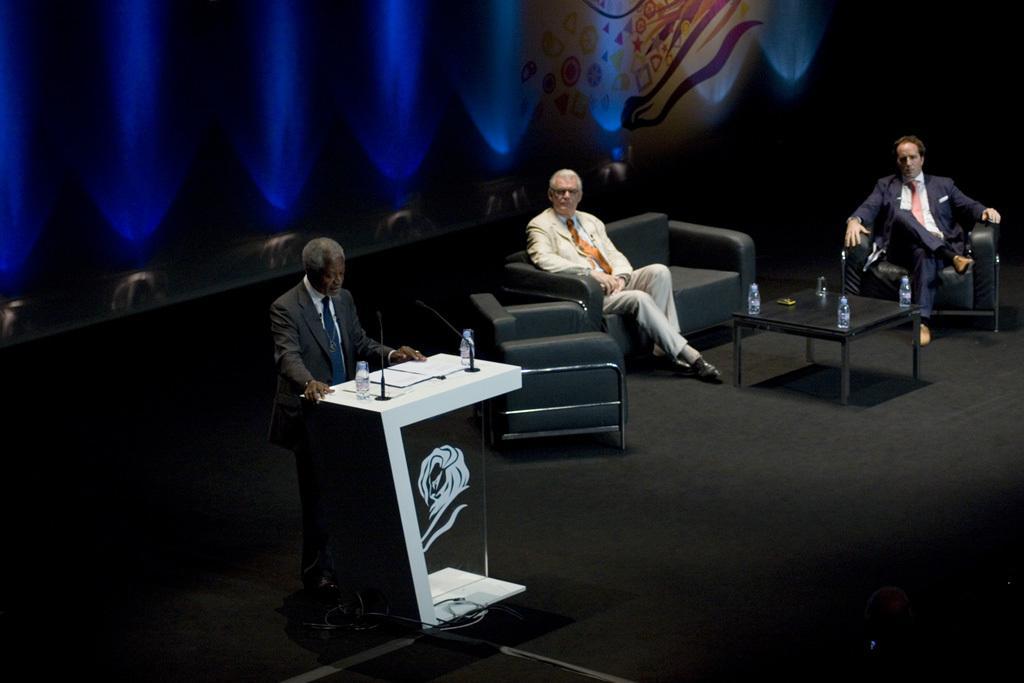In one or two sentences, can you explain what this image depicts? In this image there are three person the left-side the person is standing in front of the podium. There is a mic. On the right side the two persons are sitting on the couch. There is a table on the floor. 